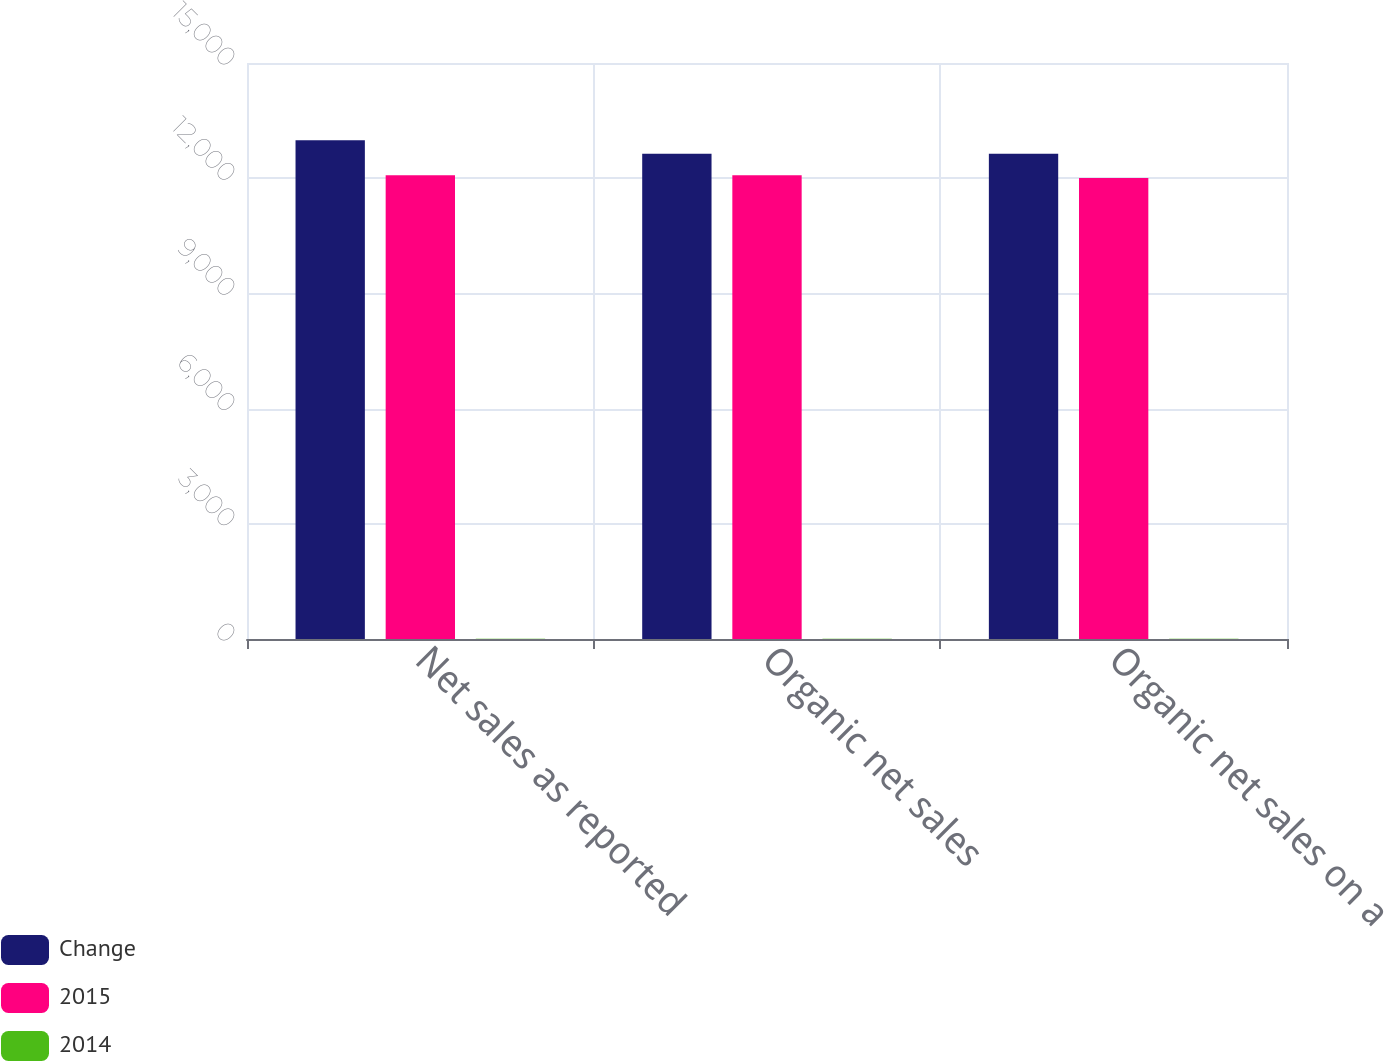Convert chart to OTSL. <chart><loc_0><loc_0><loc_500><loc_500><stacked_bar_chart><ecel><fcel>Net sales as reported<fcel>Organic net sales<fcel>Organic net sales on a<nl><fcel>Change<fcel>12988.7<fcel>12638<fcel>12638<nl><fcel>2015<fcel>12074.5<fcel>12074.5<fcel>12003<nl><fcel>2014<fcel>7.6<fcel>4.7<fcel>5.3<nl></chart> 